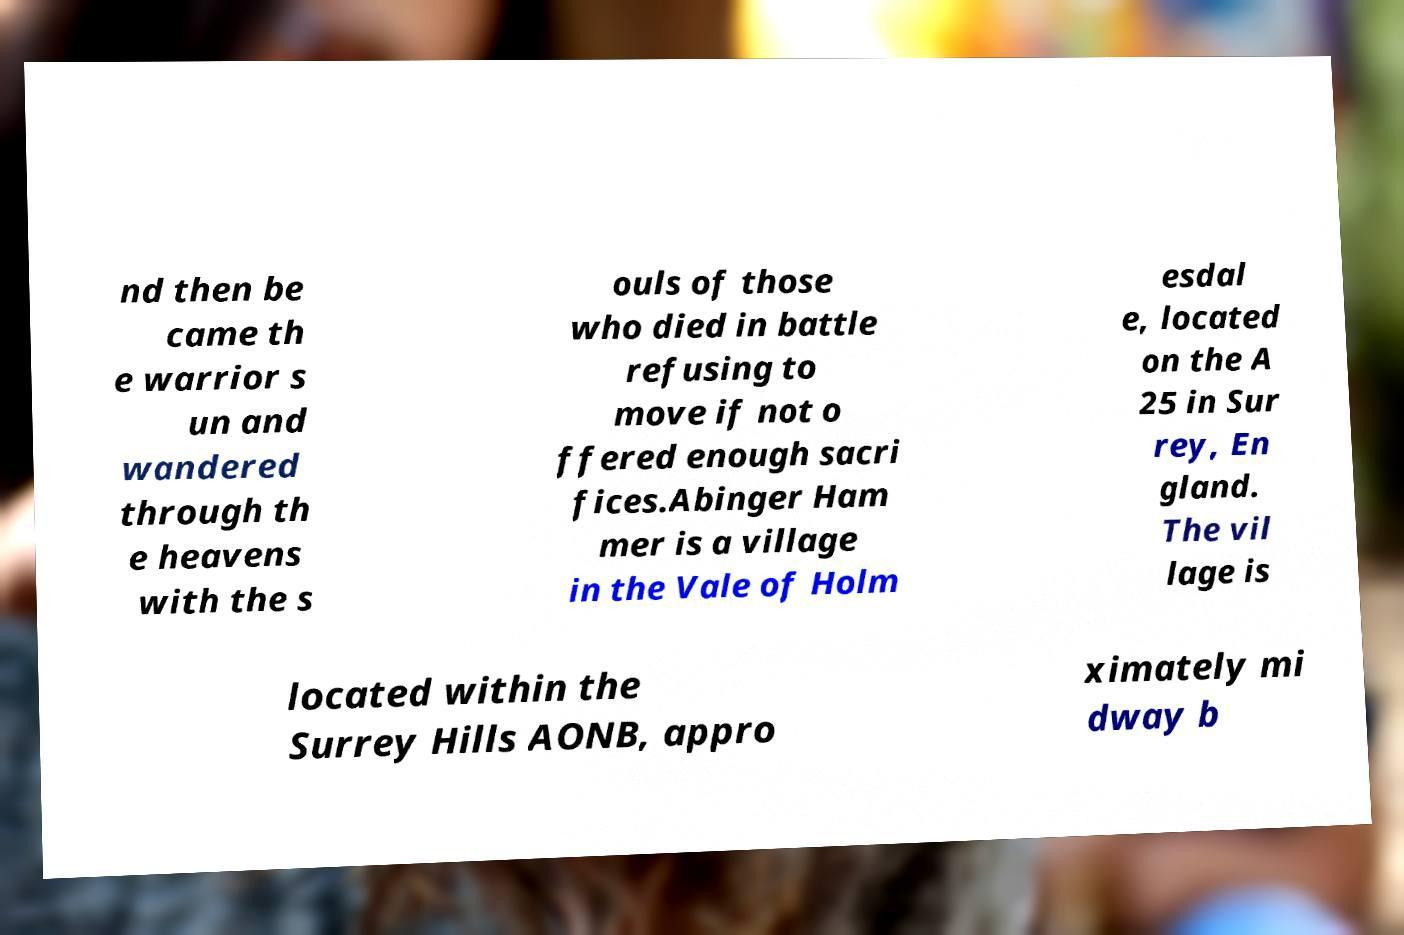I need the written content from this picture converted into text. Can you do that? nd then be came th e warrior s un and wandered through th e heavens with the s ouls of those who died in battle refusing to move if not o ffered enough sacri fices.Abinger Ham mer is a village in the Vale of Holm esdal e, located on the A 25 in Sur rey, En gland. The vil lage is located within the Surrey Hills AONB, appro ximately mi dway b 